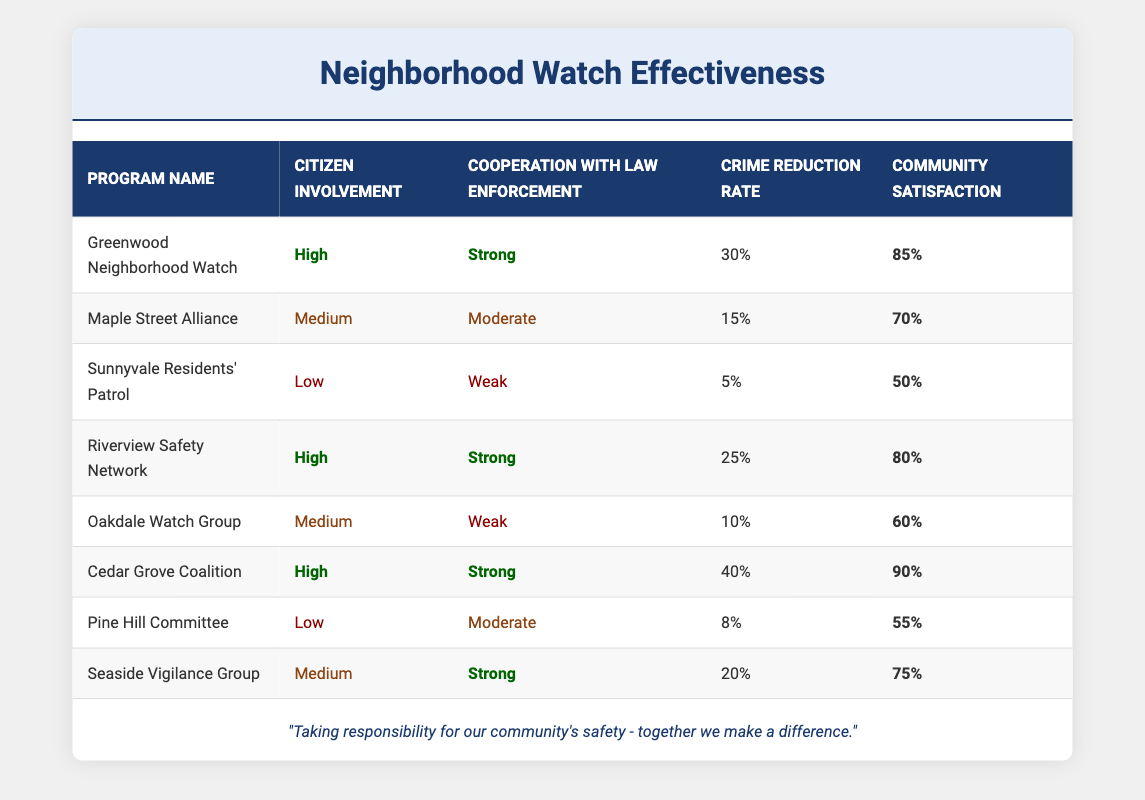What is the crime reduction rate for the Cedar Grove Coalition? The Cedar Grove Coalition has a crime reduction rate listed in the table as 40%.
Answer: 40% Which neighborhood watch program has the highest community satisfaction? The table shows that the Cedar Grove Coalition has the highest community satisfaction at 90%.
Answer: Cedar Grove Coalition Is citizen involvement low for the Sunnyvale Residents' Patrol? The table indicates that the Sunnyvale Residents' Patrol has a citizen involvement level marked as Low.
Answer: Yes What is the average crime reduction rate for programs with strong cooperation with law enforcement? The programs with strong cooperation with law enforcement are Greenwood Neighborhood Watch (30%), Riverview Safety Network (25%), Cedar Grove Coalition (40%), and Seaside Vigilance Group (20%). The average is calculated as (30 + 25 + 40 + 20) / 4 = 28.75%.
Answer: 28.75% Do programs with medium citizen involvement generally have higher community satisfaction than those with low? Based on the table, the community satisfaction for medium citizen involvement (Maple Street Alliance: 70%, Seaside Vigilance Group: 75%) averages to 72.5%. The low involvement programs (Sunnyvale Residents' Patrol: 50%, Pine Hill Committee: 55%) average to 52.5%. Hence, medium involvement does generally have higher community satisfaction.
Answer: Yes How many programs have high citizen involvement and what is their average crime reduction rate? The programs with high citizen involvement are Greenwood Neighborhood Watch (30%), Riverview Safety Network (25%), and Cedar Grove Coalition (40%). There are three programs, and their average crime reduction rate is calculated as (30 + 25 + 40) / 3 = 31.67%.
Answer: 3 programs, 31.67% Which program has medium citizen involvement and weak cooperation with law enforcement? The table indicates that the Oakdale Watch Group has medium citizen involvement and weak cooperation with law enforcement.
Answer: Oakdale Watch Group Is the community satisfaction compatible with the crime reduction rate in the Sunnyvale Residents' Patrol? The Sunnyvale Residents' Patrol has a crime reduction rate of 5% and a community satisfaction of 50%. This suggests a discrepancy since low crime reduction doesn't correspond to high satisfaction.
Answer: No What is the difference in community satisfaction between the Green Neighborhood Watch and the Pine Hill Committee? Greenwood Neighborhood Watch has a community satisfaction of 85%, while Pine Hill Committee has 55%. The difference is 85 - 55 = 30.
Answer: 30 